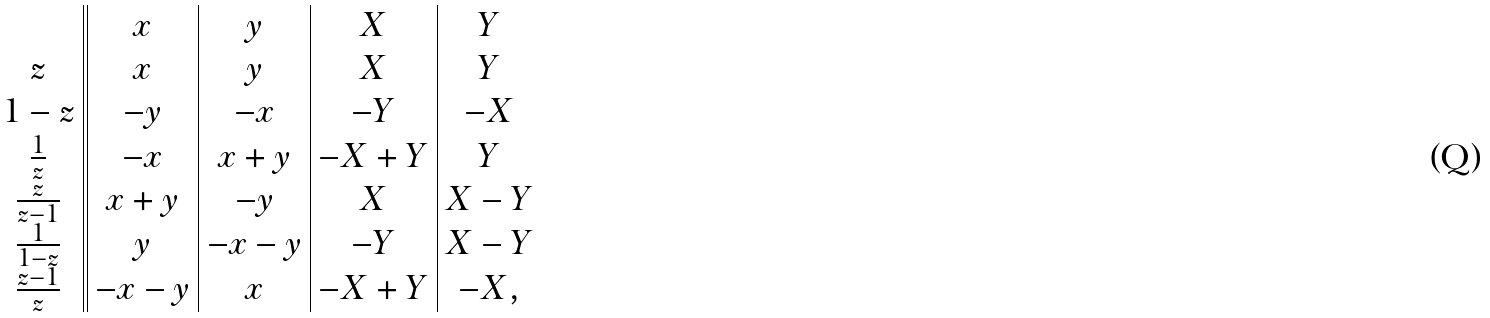<formula> <loc_0><loc_0><loc_500><loc_500>\begin{array} [ t b ] { c | | c | c | c | c } & x & y & X & Y \\ z & x & y & X & Y \\ 1 - z & - y & - x & - Y & - X \\ \frac { 1 } { z } & - x & x + y & - X + Y & Y \\ \frac { z } { z - 1 } & x + y & - y & X & X - Y \\ \frac { 1 } { 1 - z } & y & - x - y & - Y & X - Y \\ \frac { z - 1 } { z } & - x - y & x & - X + Y & - X , \end{array}</formula> 